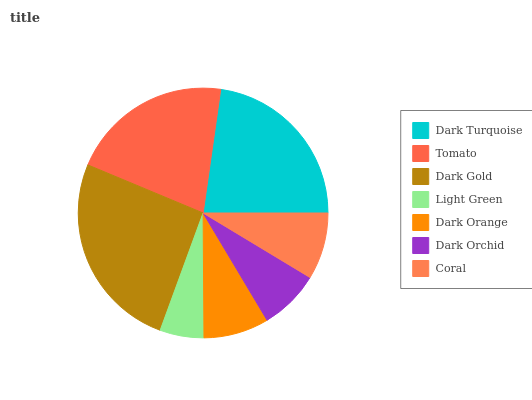Is Light Green the minimum?
Answer yes or no. Yes. Is Dark Gold the maximum?
Answer yes or no. Yes. Is Tomato the minimum?
Answer yes or no. No. Is Tomato the maximum?
Answer yes or no. No. Is Dark Turquoise greater than Tomato?
Answer yes or no. Yes. Is Tomato less than Dark Turquoise?
Answer yes or no. Yes. Is Tomato greater than Dark Turquoise?
Answer yes or no. No. Is Dark Turquoise less than Tomato?
Answer yes or no. No. Is Coral the high median?
Answer yes or no. Yes. Is Coral the low median?
Answer yes or no. Yes. Is Dark Orange the high median?
Answer yes or no. No. Is Light Green the low median?
Answer yes or no. No. 